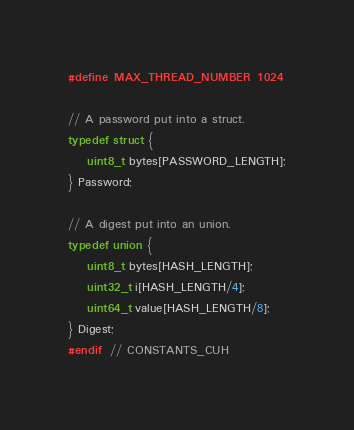<code> <loc_0><loc_0><loc_500><loc_500><_Cuda_>#define MAX_THREAD_NUMBER 1024

// A password put into a struct.
typedef struct {
    uint8_t bytes[PASSWORD_LENGTH];
} Password;

// A digest put into an union.
typedef union {
    uint8_t bytes[HASH_LENGTH];
    uint32_t i[HASH_LENGTH/4];
    uint64_t value[HASH_LENGTH/8];
} Digest;
#endif  // CONSTANTS_CUH
</code> 